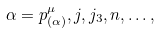Convert formula to latex. <formula><loc_0><loc_0><loc_500><loc_500>\alpha = p ^ { \mu } _ { ( \alpha ) } , j , j _ { 3 } , n , \dots ,</formula> 